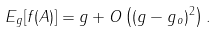<formula> <loc_0><loc_0><loc_500><loc_500>E _ { g } [ f ( A ) ] = g + O \left ( ( g - g _ { o } ) ^ { 2 } \right ) .</formula> 